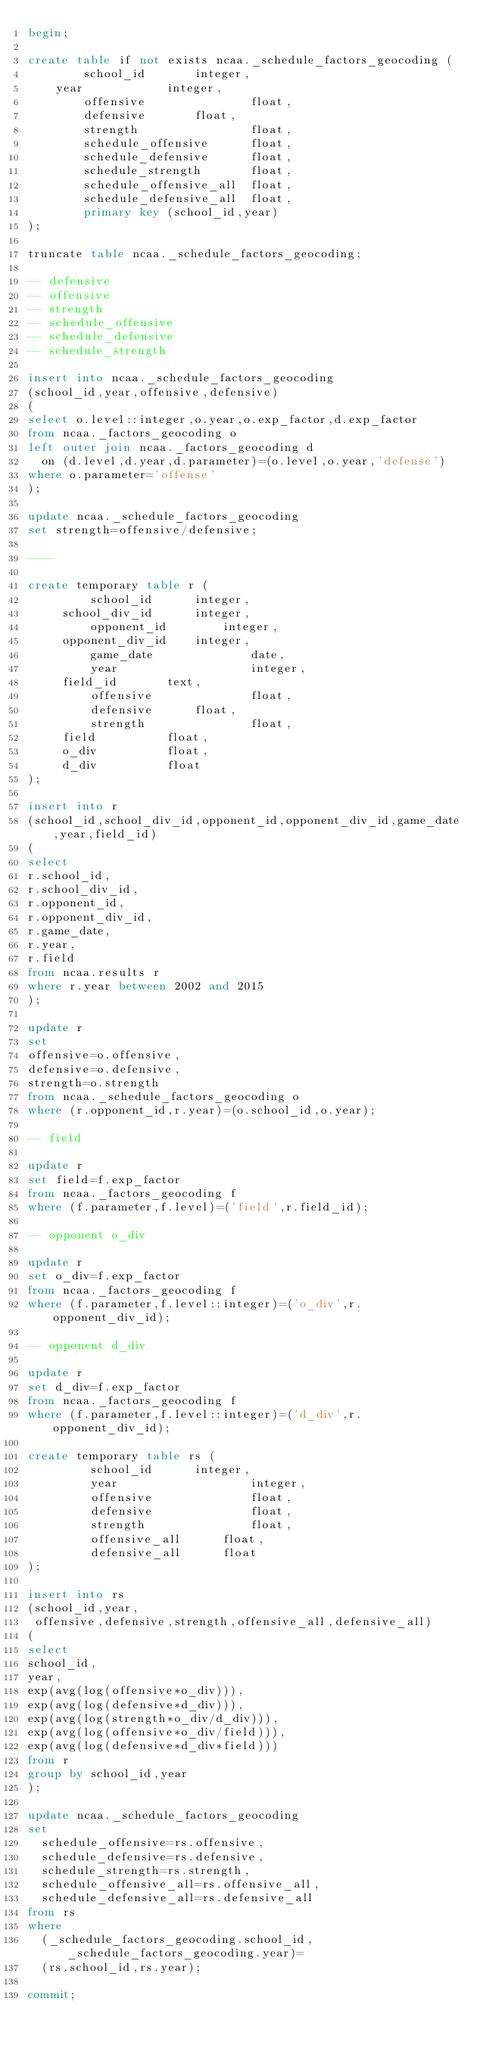<code> <loc_0><loc_0><loc_500><loc_500><_SQL_>begin;

create table if not exists ncaa._schedule_factors_geocoding (
        school_id		integer,
	year			integer,
        offensive               float,
        defensive		float,
        strength                float,
        schedule_offensive      float,
        schedule_defensive      float,
        schedule_strength       float,
        schedule_offensive_all	float,
        schedule_defensive_all	float,
        primary key (school_id,year)
);

truncate table ncaa._schedule_factors_geocoding;

-- defensive
-- offensive
-- strength 
-- schedule_offensive
-- schedule_defensive
-- schedule_strength 

insert into ncaa._schedule_factors_geocoding
(school_id,year,offensive,defensive)
(
select o.level::integer,o.year,o.exp_factor,d.exp_factor
from ncaa._factors_geocoding o
left outer join ncaa._factors_geocoding d
  on (d.level,d.year,d.parameter)=(o.level,o.year,'defense')
where o.parameter='offense'
);

update ncaa._schedule_factors_geocoding
set strength=offensive/defensive;

----

create temporary table r (
         school_id		integer,
	 school_div_id		integer,
         opponent_id		integer,
	 opponent_div_id	integer,
         game_date              date,
         year                   integer,
	 field_id		text,
         offensive              float,
         defensive		float,
         strength               float,
	 field			float,
	 o_div			float,
	 d_div			float
);

insert into r
(school_id,school_div_id,opponent_id,opponent_div_id,game_date,year,field_id)
(
select
r.school_id,
r.school_div_id,
r.opponent_id,
r.opponent_div_id,
r.game_date,
r.year,
r.field
from ncaa.results r
where r.year between 2002 and 2015
);

update r
set
offensive=o.offensive,
defensive=o.defensive,
strength=o.strength
from ncaa._schedule_factors_geocoding o
where (r.opponent_id,r.year)=(o.school_id,o.year);

-- field

update r
set field=f.exp_factor
from ncaa._factors_geocoding f
where (f.parameter,f.level)=('field',r.field_id);

-- opponent o_div

update r
set o_div=f.exp_factor
from ncaa._factors_geocoding f
where (f.parameter,f.level::integer)=('o_div',r.opponent_div_id);

-- opponent d_div

update r
set d_div=f.exp_factor
from ncaa._factors_geocoding f
where (f.parameter,f.level::integer)=('d_div',r.opponent_div_id);

create temporary table rs (
         school_id		integer,
         year                   integer,
         offensive              float,
         defensive              float,
         strength               float,
         offensive_all		float,
         defensive_all		float
);

insert into rs
(school_id,year,
 offensive,defensive,strength,offensive_all,defensive_all)
(
select
school_id,
year,
exp(avg(log(offensive*o_div))),
exp(avg(log(defensive*d_div))),
exp(avg(log(strength*o_div/d_div))),
exp(avg(log(offensive*o_div/field))),
exp(avg(log(defensive*d_div*field)))
from r
group by school_id,year
);

update ncaa._schedule_factors_geocoding
set
  schedule_offensive=rs.offensive,
  schedule_defensive=rs.defensive,
  schedule_strength=rs.strength,
  schedule_offensive_all=rs.offensive_all,
  schedule_defensive_all=rs.defensive_all
from rs
where
  (_schedule_factors_geocoding.school_id,_schedule_factors_geocoding.year)=
  (rs.school_id,rs.year);

commit;
</code> 